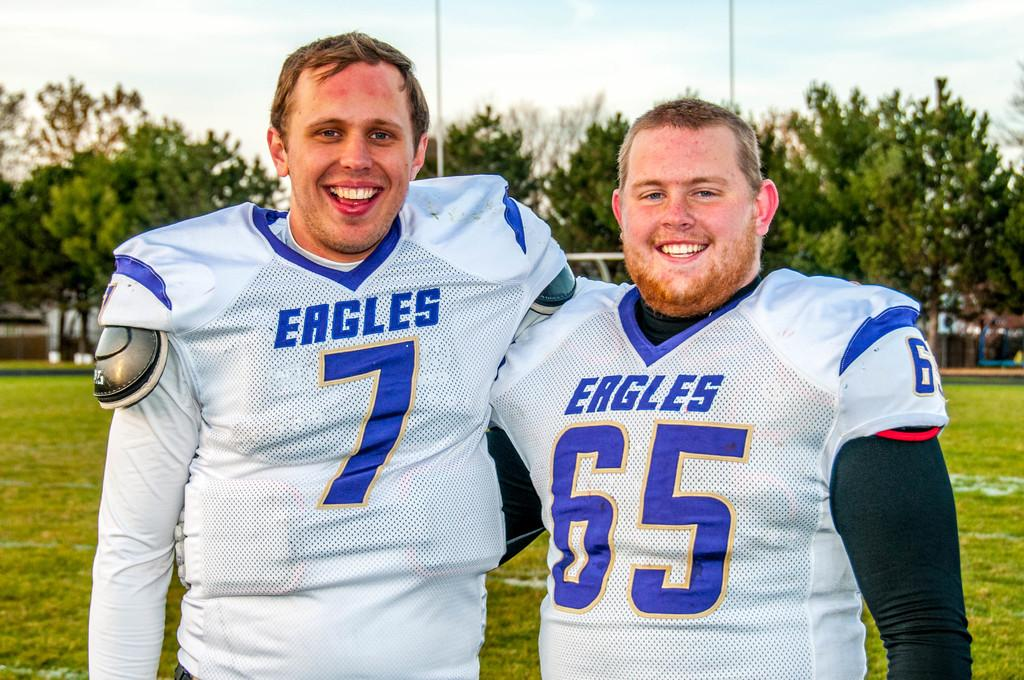<image>
Present a compact description of the photo's key features. the two men are wearing Eagles jersey number 7 and 65 